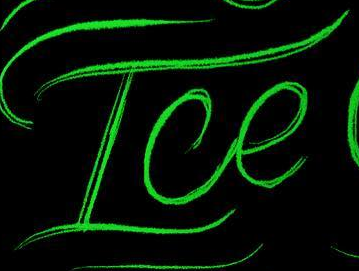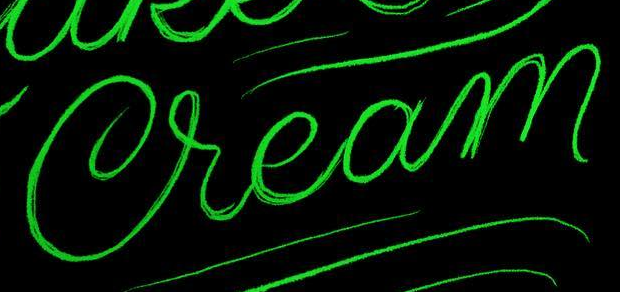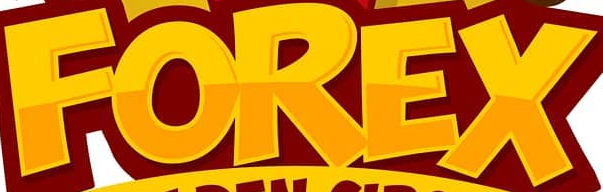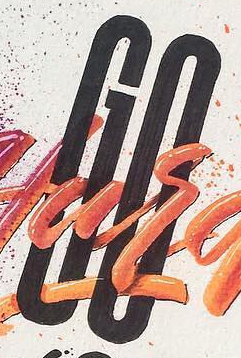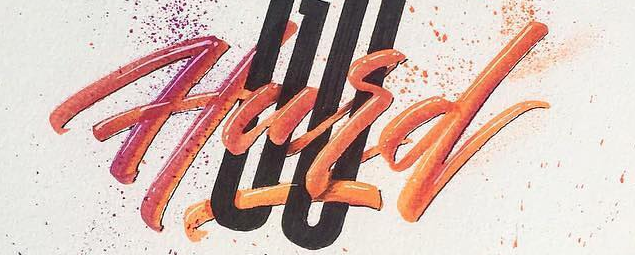Transcribe the words shown in these images in order, separated by a semicolon. Ice; Cream; FOREX; GO; Hard 